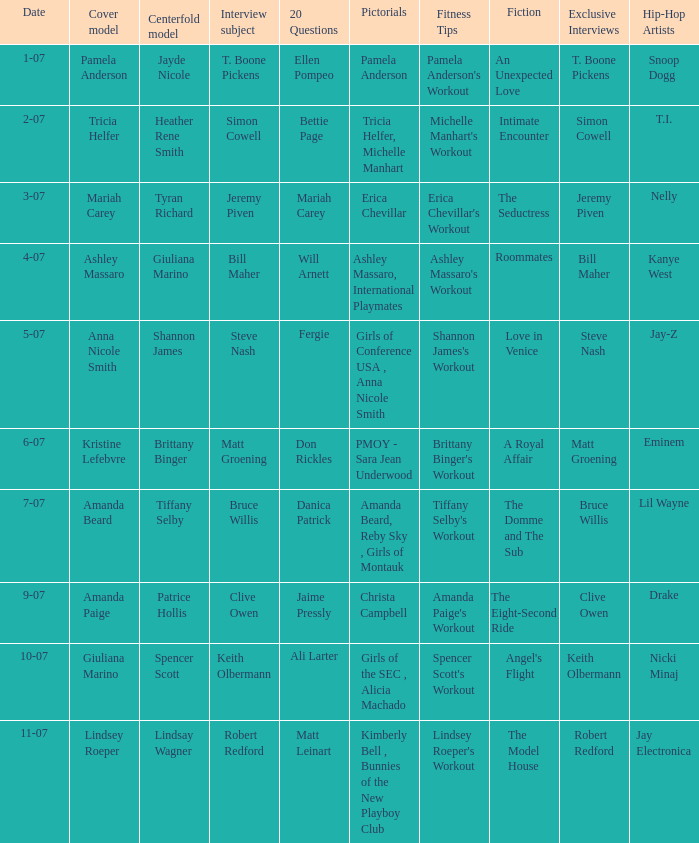List the pictorals from issues when lindsey roeper was the cover model. Kimberly Bell , Bunnies of the New Playboy Club. 